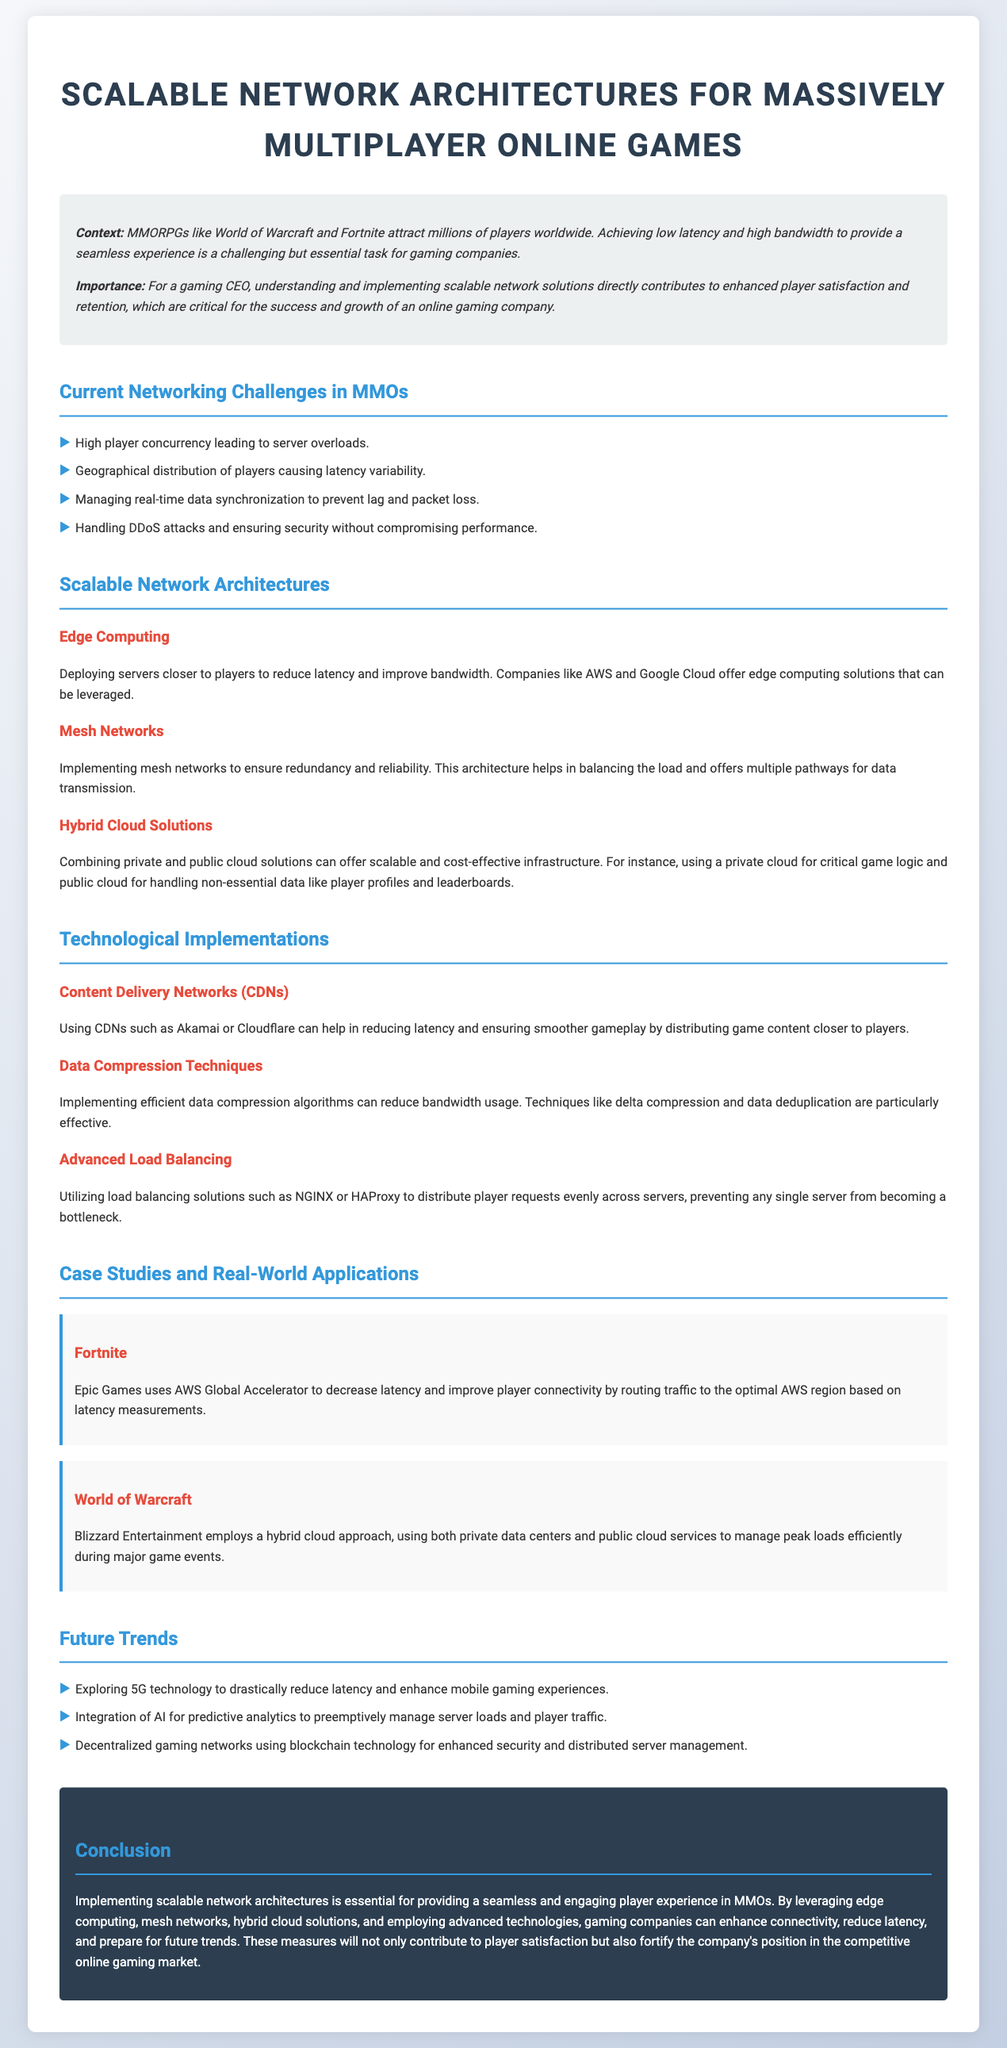what is the main context discussed in the document? The document focuses on the challenges and solutions for achieving low latency and high bandwidth in MMORPGs to enhance player experiences.
Answer: MMORPGs and online gaming experiences name two key networking challenges mentioned. The document lists several challenges, two of which include high player concurrency leading to server overloads and geographical distribution causing latency variability.
Answer: High player concurrency, geographical distribution what technology does Epic Games use to decrease latency in Fortnite? Epic Games uses AWS Global Accelerator to improve connectivity by routing traffic to the optimal AWS region.
Answer: AWS Global Accelerator which game utilizes a hybrid cloud approach according to the case studies? Blizzard Entertainment's World of Warcraft is noted for employing a hybrid cloud approach to manage peak loads.
Answer: World of Warcraft what future trend is mentioned for mobile gaming experiences? The document highlights the exploration of 5G technology as a future trend to enhance mobile gaming experiences.
Answer: 5G technology how does the document describe the impact of scalable network architectures on player satisfaction? It states that implementing scalable architectures is essential for providing a seamless and engaging player experience, directly contributing to player satisfaction.
Answer: Seamless and engaging player experience what type of networks does the document suggest to ensure redundancy and reliability? The document suggests implementing mesh networks to ensure redundancy and reliability in the gaming infrastructure.
Answer: Mesh networks which companies are mentioned as offering edge computing solutions? The document specifically mentions AWS and Google Cloud as providers of edge computing solutions.
Answer: AWS and Google Cloud 